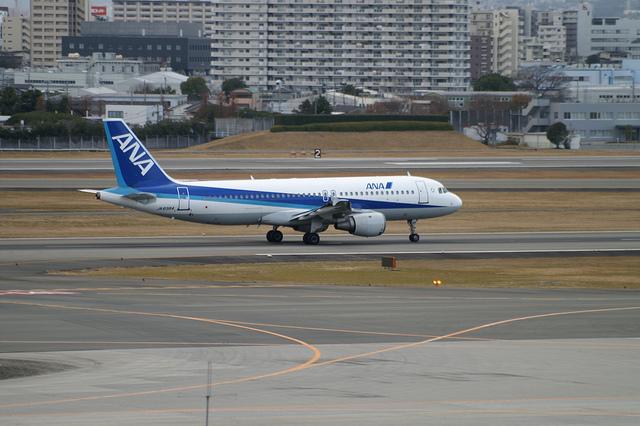Is the plane landing or taking off?
Keep it brief. Landing. What kind of climate is in this photo?
Keep it brief. Damp. How many houses can you count in the background behind the plane?
Quick response, please. 0. Is the plane on a runway?
Write a very short answer. Yes. What does the plane have written on its tail?
Answer briefly. Ana. What is the tower in the background?
Concise answer only. Apartments. What kind of plane is it?
Be succinct. Ana. How many planes are there?
Short answer required. 1. What is under the plane?
Short answer required. Runway. 